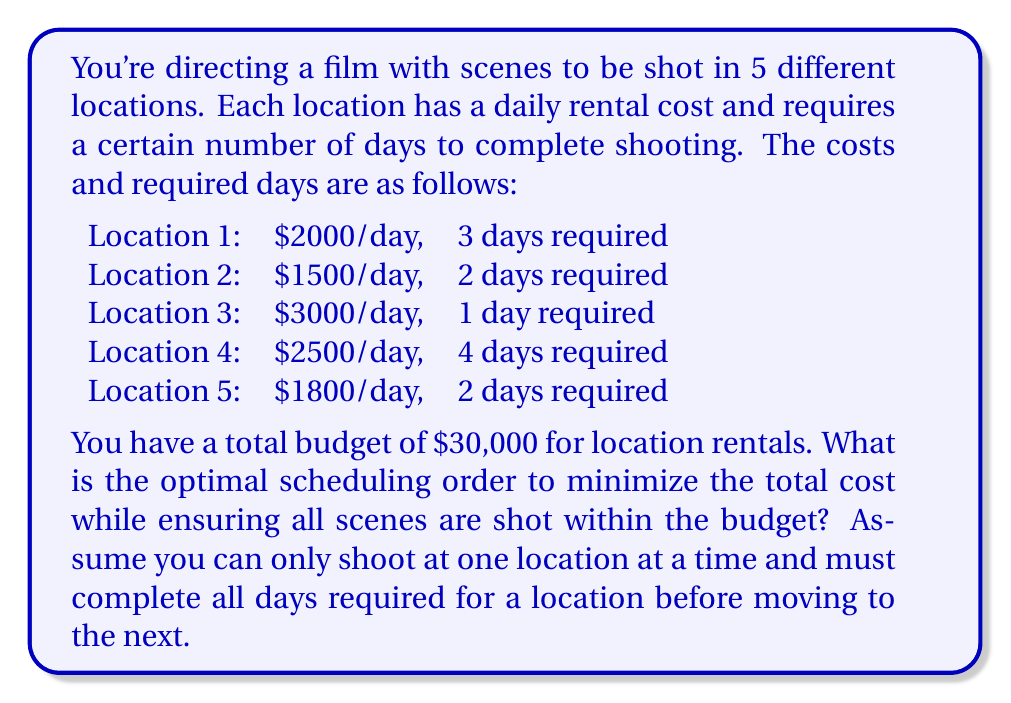Help me with this question. To solve this problem, we can use the greedy algorithm approach, specifically the concept of scheduling to minimize weighted completion time. In this case, the weight is the daily rental cost, and the completion time is the number of days required.

Step 1: Calculate the cost-effectiveness ratio for each location.
Cost-effectiveness ratio = Daily rental cost / Number of days required

Location 1: $2000 / 3 = $666.67 per day
Location 2: $1500 / 2 = $750 per day
Location 3: $3000 / 1 = $3000 per day
Location 4: $2500 / 4 = $625 per day
Location 5: $1800 / 2 = $900 per day

Step 2: Sort the locations based on their cost-effectiveness ratio in ascending order.
Location 4, Location 1, Location 2, Location 5, Location 3

Step 3: Calculate the cumulative cost for this order:
Location 4: $2500 * 4 = $10,000
Location 1: $2000 * 3 = $6,000
Location 2: $1500 * 2 = $3,000
Location 5: $1800 * 2 = $3,600
Location 3: $3000 * 1 = $3,000

Total cost: $10,000 + $6,000 + $3,000 + $3,600 + $3,000 = $25,600

Step 4: Verify that the total cost is within the budget of $30,000.

This scheduling order minimizes the total cost while ensuring all scenes are shot within the budget.
Answer: The optimal scheduling order is: Location 4, Location 1, Location 2, Location 5, Location 3. The total cost is $25,600, which is within the $30,000 budget. 